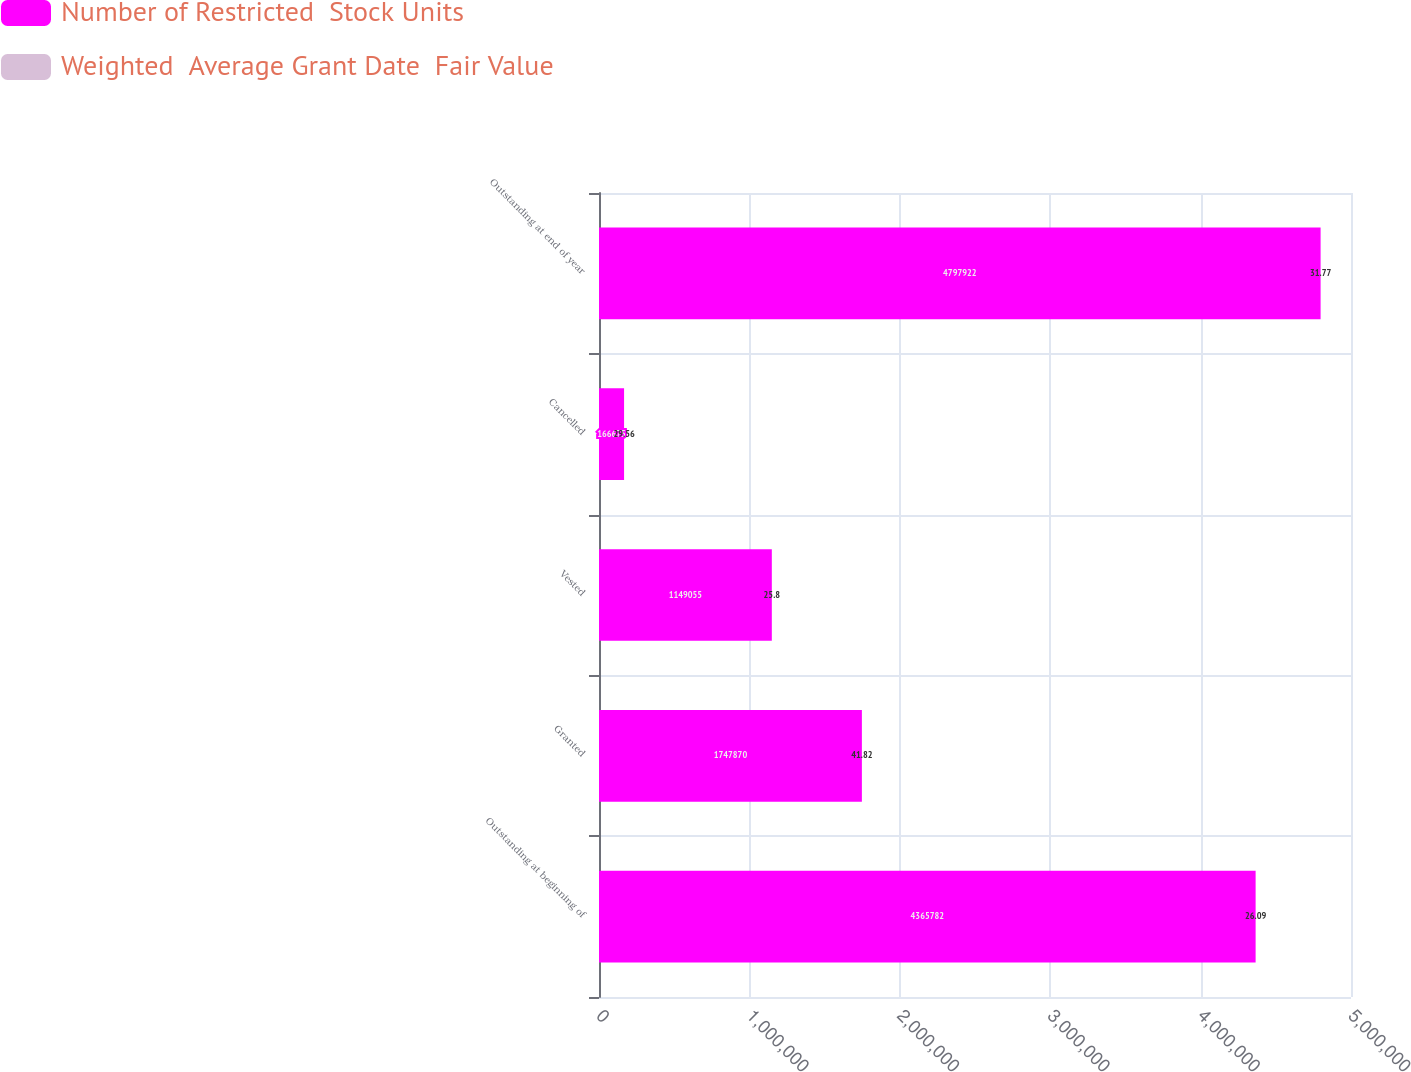<chart> <loc_0><loc_0><loc_500><loc_500><stacked_bar_chart><ecel><fcel>Outstanding at beginning of<fcel>Granted<fcel>Vested<fcel>Cancelled<fcel>Outstanding at end of year<nl><fcel>Number of Restricted  Stock Units<fcel>4.36578e+06<fcel>1.74787e+06<fcel>1.14906e+06<fcel>166675<fcel>4.79792e+06<nl><fcel>Weighted  Average Grant Date  Fair Value<fcel>26.09<fcel>41.82<fcel>25.8<fcel>29.56<fcel>31.77<nl></chart> 